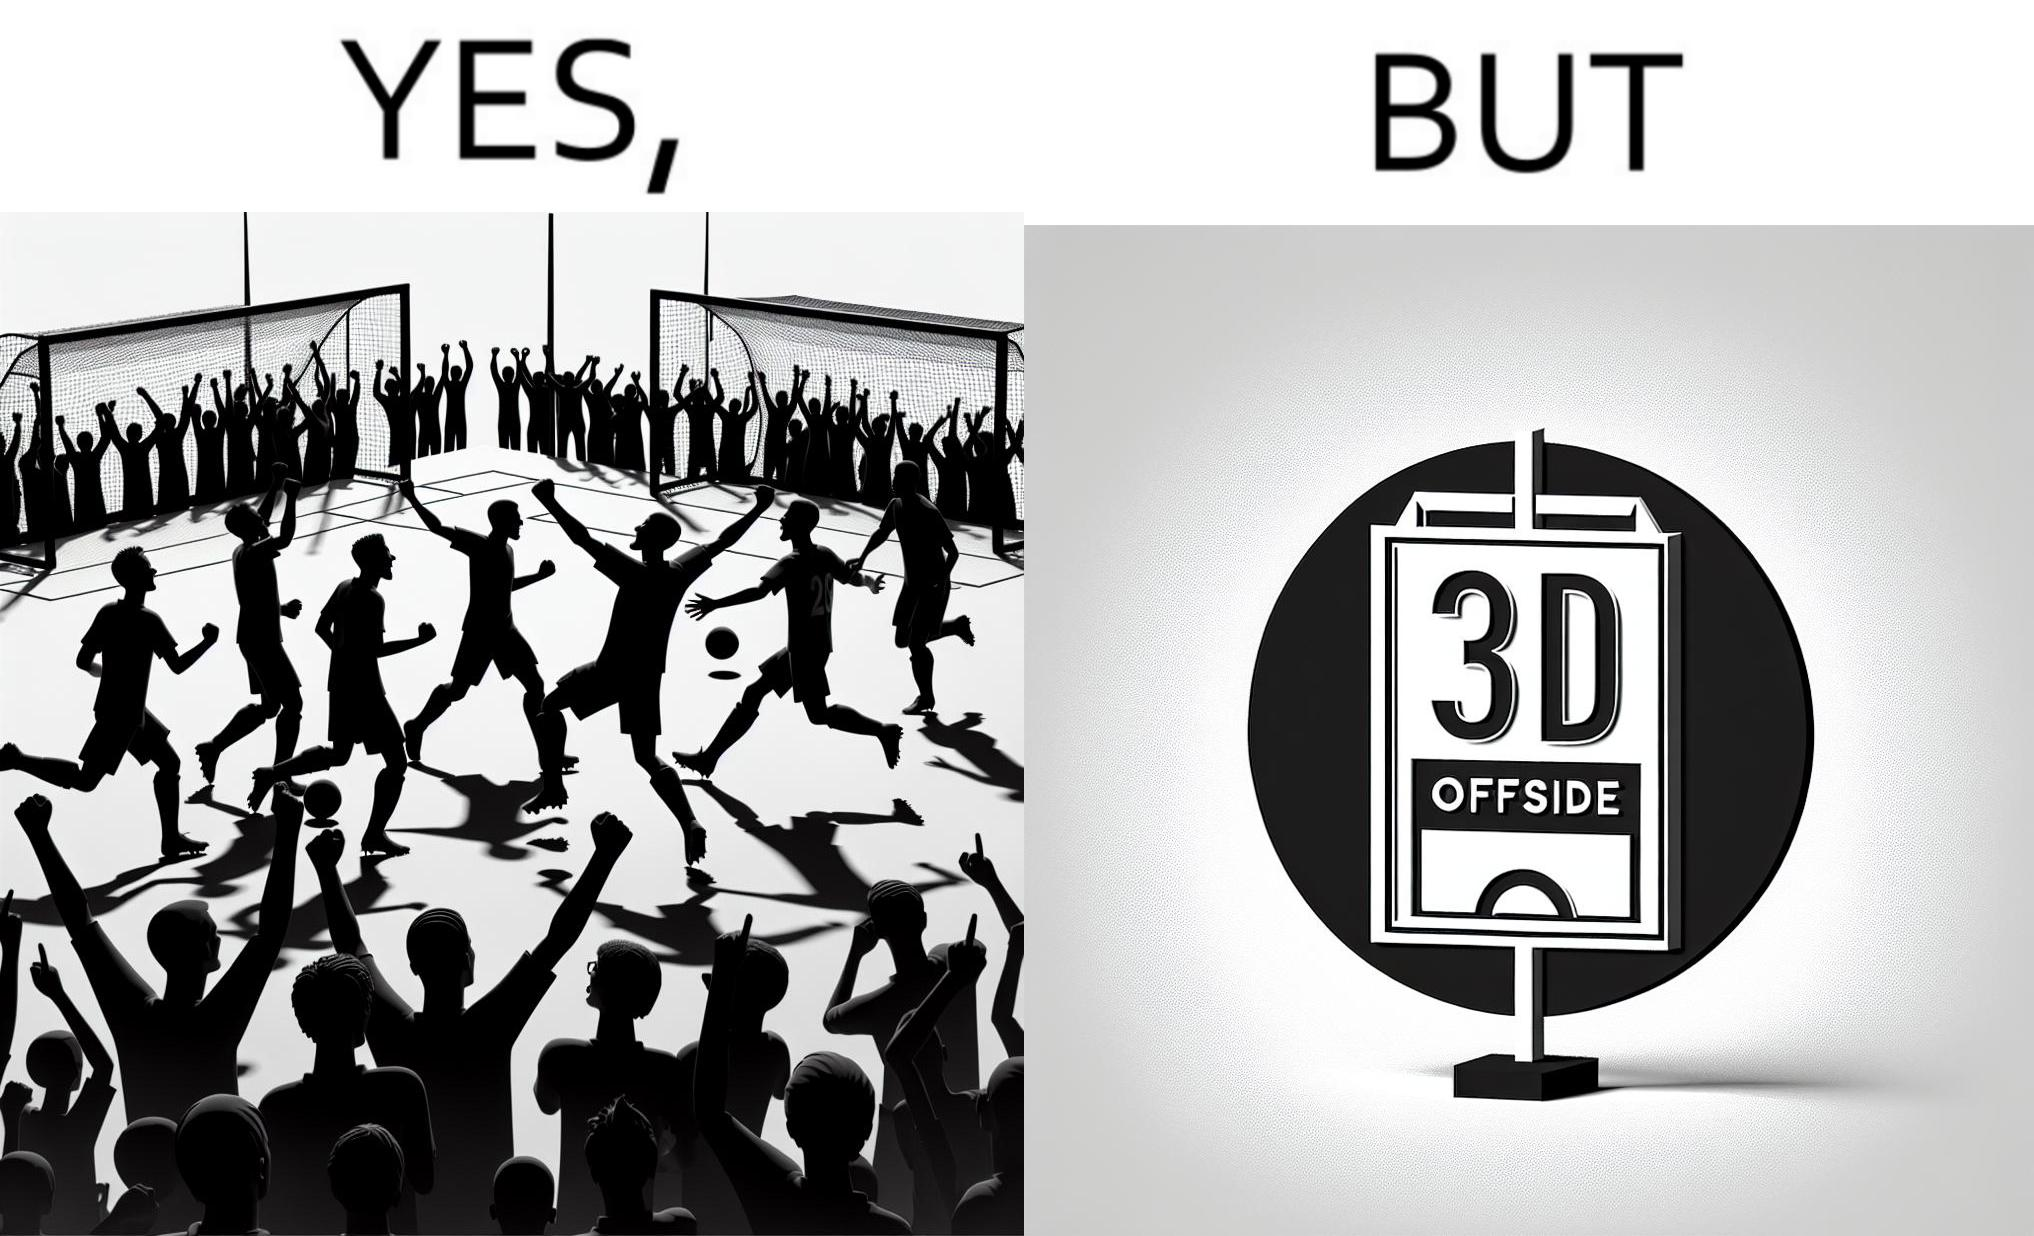What is the satirical meaning behind this image? The image is ironical, as the team is celebrating as they think that they have scored a goal, but the sign on the screen says that it is an offside, and not a goal. This is a very common scenario in football matches. 